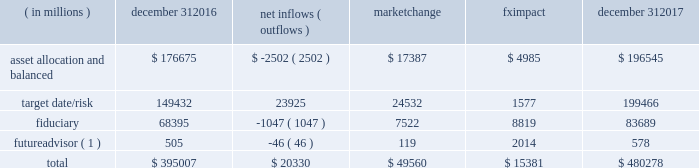Long-term product offerings include alpha-seeking active and index strategies .
Our alpha-seeking active strategies seek to earn attractive returns in excess of a market benchmark or performance hurdle while maintaining an appropriate risk profile , and leverage fundamental research and quantitative models to drive portfolio construction .
In contrast , index strategies seek to closely track the returns of a corresponding index , generally by investing in substantially the same underlying securities within the index or in a subset of those securities selected to approximate a similar risk and return profile of the index .
Index strategies include both our non-etf index products and ishares etfs .
Although many clients use both alpha-seeking active and index strategies , the application of these strategies may differ .
For example , clients may use index products to gain exposure to a market or asset class , or may use a combination of index strategies to target active returns .
In addition , institutional non-etf index assignments tend to be very large ( multi-billion dollars ) and typically reflect low fee rates .
Net flows in institutional index products generally have a small impact on blackrock 2019s revenues and earnings .
Equity year-end 2017 equity aum totaled $ 3.372 trillion , reflecting net inflows of $ 130.1 billion .
Net inflows included $ 174.4 billion into ishares etfs , driven by net inflows into core funds and broad developed and emerging market equities , partially offset by non-etf index and active net outflows of $ 25.7 billion and $ 18.5 billion , respectively .
Blackrock 2019s effective fee rates fluctuate due to changes in aum mix .
Approximately half of blackrock 2019s equity aum is tied to international markets , including emerging markets , which tend to have higher fee rates than u.s .
Equity strategies .
Accordingly , fluctuations in international equity markets , which may not consistently move in tandem with u.s .
Markets , have a greater impact on blackrock 2019s equity revenues and effective fee rate .
Fixed income fixed income aum ended 2017 at $ 1.855 trillion , reflecting net inflows of $ 178.8 billion .
In 2017 , active net inflows of $ 21.5 billion were diversified across fixed income offerings , and included strong inflows into municipal , unconstrained and total return bond funds .
Ishares etfs net inflows of $ 67.5 billion were led by flows into core , corporate and treasury bond funds .
Non-etf index net inflows of $ 89.8 billion were driven by demand for liability-driven investment solutions .
Multi-asset blackrock 2019s multi-asset team manages a variety of balanced funds and bespoke mandates for a diversified client base that leverages our broad investment expertise in global equities , bonds , currencies and commodities , and our extensive risk management capabilities .
Investment solutions might include a combination of long-only portfolios and alternative investments as well as tactical asset allocation overlays .
Component changes in multi-asset aum for 2017 are presented below .
( in millions ) december 31 , net inflows ( outflows ) market change impact december 31 .
( 1 ) futureadvisor amounts do not include aum held in ishares etfs .
Multi-asset net inflows reflected ongoing institutional demand for our solutions-based advice with $ 18.9 billion of net inflows coming from institutional clients .
Defined contribution plans of institutional clients remained a significant driver of flows , and contributed $ 20.8 billion to institutional multi-asset net inflows in 2017 , primarily into target date and target risk product offerings .
Retail net inflows of $ 1.1 billion reflected demand for our multi-asset income fund family , which raised $ 5.8 billion in 2017 .
The company 2019s multi-asset strategies include the following : 2022 asset allocation and balanced products represented 41% ( 41 % ) of multi-asset aum at year-end .
These strategies combine equity , fixed income and alternative components for investors seeking a tailored solution relative to a specific benchmark and within a risk budget .
In certain cases , these strategies seek to minimize downside risk through diversification , derivatives strategies and tactical asset allocation decisions .
Flagship products in this category include our global allocation and multi-asset income fund families .
2022 target date and target risk products grew 16% ( 16 % ) organically in 2017 , with net inflows of $ 23.9 billion .
Institutional investors represented 93% ( 93 % ) of target date and target risk aum , with defined contribution plans accounting for 87% ( 87 % ) of aum .
Flows were driven by defined contribution investments in our lifepath offerings .
Lifepath products utilize a proprietary active asset allocation overlay model that seeks to balance risk and return over an investment horizon based on the investor 2019s expected retirement timing .
Underlying investments are primarily index products .
2022 fiduciary management services are complex mandates in which pension plan sponsors or endowments and foundations retain blackrock to assume responsibility for some or all aspects of investment management .
These customized services require strong partnership with the clients 2019 investment staff and trustees in order to tailor investment strategies to meet client-specific risk budgets and return objectives. .
What is the percentage change in the balance of target date/risk from 2016 to 2017? 
Computations: ((199466 - 149432) / 149432)
Answer: 0.33483. Long-term product offerings include alpha-seeking active and index strategies .
Our alpha-seeking active strategies seek to earn attractive returns in excess of a market benchmark or performance hurdle while maintaining an appropriate risk profile , and leverage fundamental research and quantitative models to drive portfolio construction .
In contrast , index strategies seek to closely track the returns of a corresponding index , generally by investing in substantially the same underlying securities within the index or in a subset of those securities selected to approximate a similar risk and return profile of the index .
Index strategies include both our non-etf index products and ishares etfs .
Although many clients use both alpha-seeking active and index strategies , the application of these strategies may differ .
For example , clients may use index products to gain exposure to a market or asset class , or may use a combination of index strategies to target active returns .
In addition , institutional non-etf index assignments tend to be very large ( multi-billion dollars ) and typically reflect low fee rates .
Net flows in institutional index products generally have a small impact on blackrock 2019s revenues and earnings .
Equity year-end 2017 equity aum totaled $ 3.372 trillion , reflecting net inflows of $ 130.1 billion .
Net inflows included $ 174.4 billion into ishares etfs , driven by net inflows into core funds and broad developed and emerging market equities , partially offset by non-etf index and active net outflows of $ 25.7 billion and $ 18.5 billion , respectively .
Blackrock 2019s effective fee rates fluctuate due to changes in aum mix .
Approximately half of blackrock 2019s equity aum is tied to international markets , including emerging markets , which tend to have higher fee rates than u.s .
Equity strategies .
Accordingly , fluctuations in international equity markets , which may not consistently move in tandem with u.s .
Markets , have a greater impact on blackrock 2019s equity revenues and effective fee rate .
Fixed income fixed income aum ended 2017 at $ 1.855 trillion , reflecting net inflows of $ 178.8 billion .
In 2017 , active net inflows of $ 21.5 billion were diversified across fixed income offerings , and included strong inflows into municipal , unconstrained and total return bond funds .
Ishares etfs net inflows of $ 67.5 billion were led by flows into core , corporate and treasury bond funds .
Non-etf index net inflows of $ 89.8 billion were driven by demand for liability-driven investment solutions .
Multi-asset blackrock 2019s multi-asset team manages a variety of balanced funds and bespoke mandates for a diversified client base that leverages our broad investment expertise in global equities , bonds , currencies and commodities , and our extensive risk management capabilities .
Investment solutions might include a combination of long-only portfolios and alternative investments as well as tactical asset allocation overlays .
Component changes in multi-asset aum for 2017 are presented below .
( in millions ) december 31 , net inflows ( outflows ) market change impact december 31 .
( 1 ) futureadvisor amounts do not include aum held in ishares etfs .
Multi-asset net inflows reflected ongoing institutional demand for our solutions-based advice with $ 18.9 billion of net inflows coming from institutional clients .
Defined contribution plans of institutional clients remained a significant driver of flows , and contributed $ 20.8 billion to institutional multi-asset net inflows in 2017 , primarily into target date and target risk product offerings .
Retail net inflows of $ 1.1 billion reflected demand for our multi-asset income fund family , which raised $ 5.8 billion in 2017 .
The company 2019s multi-asset strategies include the following : 2022 asset allocation and balanced products represented 41% ( 41 % ) of multi-asset aum at year-end .
These strategies combine equity , fixed income and alternative components for investors seeking a tailored solution relative to a specific benchmark and within a risk budget .
In certain cases , these strategies seek to minimize downside risk through diversification , derivatives strategies and tactical asset allocation decisions .
Flagship products in this category include our global allocation and multi-asset income fund families .
2022 target date and target risk products grew 16% ( 16 % ) organically in 2017 , with net inflows of $ 23.9 billion .
Institutional investors represented 93% ( 93 % ) of target date and target risk aum , with defined contribution plans accounting for 87% ( 87 % ) of aum .
Flows were driven by defined contribution investments in our lifepath offerings .
Lifepath products utilize a proprietary active asset allocation overlay model that seeks to balance risk and return over an investment horizon based on the investor 2019s expected retirement timing .
Underlying investments are primarily index products .
2022 fiduciary management services are complex mandates in which pension plan sponsors or endowments and foundations retain blackrock to assume responsibility for some or all aspects of investment management .
These customized services require strong partnership with the clients 2019 investment staff and trustees in order to tailor investment strategies to meet client-specific risk budgets and return objectives. .
What is the percentage change in the balance of asset allocation from 2016 to 2017? 
Computations: ((196545 - 176675) / 176675)
Answer: 0.11247. 